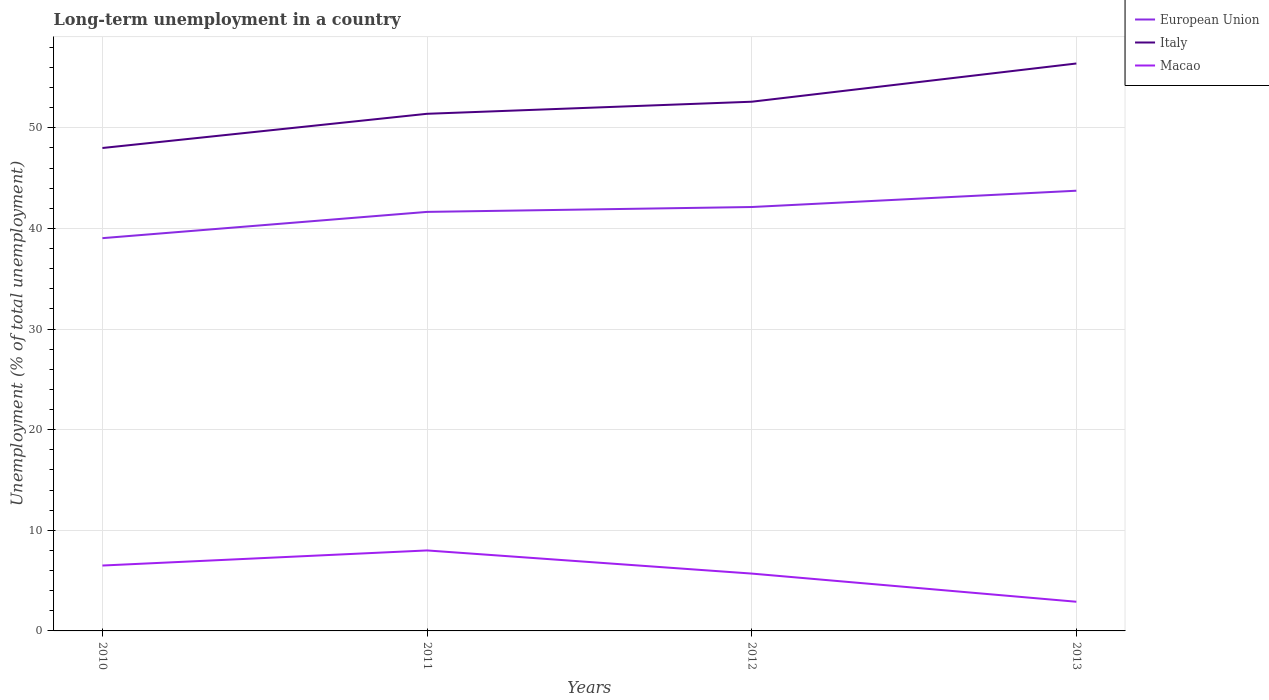Does the line corresponding to Italy intersect with the line corresponding to Macao?
Give a very brief answer. No. In which year was the percentage of long-term unemployed population in Italy maximum?
Make the answer very short. 2010. What is the total percentage of long-term unemployed population in Macao in the graph?
Your response must be concise. 5.1. What is the difference between the highest and the second highest percentage of long-term unemployed population in Italy?
Your answer should be compact. 8.4. What is the difference between the highest and the lowest percentage of long-term unemployed population in Macao?
Keep it short and to the point. 2. How many lines are there?
Ensure brevity in your answer.  3. How many years are there in the graph?
Offer a very short reply. 4. What is the difference between two consecutive major ticks on the Y-axis?
Provide a succinct answer. 10. Are the values on the major ticks of Y-axis written in scientific E-notation?
Keep it short and to the point. No. Does the graph contain any zero values?
Offer a very short reply. No. Does the graph contain grids?
Your response must be concise. Yes. How are the legend labels stacked?
Ensure brevity in your answer.  Vertical. What is the title of the graph?
Provide a short and direct response. Long-term unemployment in a country. What is the label or title of the Y-axis?
Your answer should be compact. Unemployment (% of total unemployment). What is the Unemployment (% of total unemployment) in European Union in 2010?
Your response must be concise. 39.04. What is the Unemployment (% of total unemployment) in Italy in 2010?
Offer a very short reply. 48. What is the Unemployment (% of total unemployment) in Macao in 2010?
Your answer should be very brief. 6.5. What is the Unemployment (% of total unemployment) in European Union in 2011?
Provide a short and direct response. 41.65. What is the Unemployment (% of total unemployment) of Italy in 2011?
Provide a succinct answer. 51.4. What is the Unemployment (% of total unemployment) in Macao in 2011?
Ensure brevity in your answer.  8. What is the Unemployment (% of total unemployment) of European Union in 2012?
Offer a very short reply. 42.13. What is the Unemployment (% of total unemployment) in Italy in 2012?
Your answer should be compact. 52.6. What is the Unemployment (% of total unemployment) in Macao in 2012?
Offer a terse response. 5.7. What is the Unemployment (% of total unemployment) of European Union in 2013?
Your answer should be compact. 43.75. What is the Unemployment (% of total unemployment) of Italy in 2013?
Offer a terse response. 56.4. What is the Unemployment (% of total unemployment) of Macao in 2013?
Ensure brevity in your answer.  2.9. Across all years, what is the maximum Unemployment (% of total unemployment) in European Union?
Offer a very short reply. 43.75. Across all years, what is the maximum Unemployment (% of total unemployment) of Italy?
Provide a succinct answer. 56.4. Across all years, what is the maximum Unemployment (% of total unemployment) of Macao?
Offer a terse response. 8. Across all years, what is the minimum Unemployment (% of total unemployment) of European Union?
Your response must be concise. 39.04. Across all years, what is the minimum Unemployment (% of total unemployment) of Italy?
Make the answer very short. 48. Across all years, what is the minimum Unemployment (% of total unemployment) in Macao?
Make the answer very short. 2.9. What is the total Unemployment (% of total unemployment) in European Union in the graph?
Offer a very short reply. 166.58. What is the total Unemployment (% of total unemployment) of Italy in the graph?
Make the answer very short. 208.4. What is the total Unemployment (% of total unemployment) in Macao in the graph?
Offer a terse response. 23.1. What is the difference between the Unemployment (% of total unemployment) in European Union in 2010 and that in 2011?
Your answer should be very brief. -2.61. What is the difference between the Unemployment (% of total unemployment) of Italy in 2010 and that in 2011?
Offer a terse response. -3.4. What is the difference between the Unemployment (% of total unemployment) in European Union in 2010 and that in 2012?
Keep it short and to the point. -3.09. What is the difference between the Unemployment (% of total unemployment) of Macao in 2010 and that in 2012?
Offer a terse response. 0.8. What is the difference between the Unemployment (% of total unemployment) in European Union in 2010 and that in 2013?
Offer a very short reply. -4.71. What is the difference between the Unemployment (% of total unemployment) in Macao in 2010 and that in 2013?
Offer a very short reply. 3.6. What is the difference between the Unemployment (% of total unemployment) in European Union in 2011 and that in 2012?
Offer a terse response. -0.48. What is the difference between the Unemployment (% of total unemployment) in Macao in 2011 and that in 2012?
Ensure brevity in your answer.  2.3. What is the difference between the Unemployment (% of total unemployment) of European Union in 2011 and that in 2013?
Give a very brief answer. -2.1. What is the difference between the Unemployment (% of total unemployment) in Italy in 2011 and that in 2013?
Your answer should be very brief. -5. What is the difference between the Unemployment (% of total unemployment) of Macao in 2011 and that in 2013?
Provide a succinct answer. 5.1. What is the difference between the Unemployment (% of total unemployment) of European Union in 2012 and that in 2013?
Your response must be concise. -1.62. What is the difference between the Unemployment (% of total unemployment) in Italy in 2012 and that in 2013?
Provide a short and direct response. -3.8. What is the difference between the Unemployment (% of total unemployment) in Macao in 2012 and that in 2013?
Ensure brevity in your answer.  2.8. What is the difference between the Unemployment (% of total unemployment) of European Union in 2010 and the Unemployment (% of total unemployment) of Italy in 2011?
Provide a short and direct response. -12.36. What is the difference between the Unemployment (% of total unemployment) in European Union in 2010 and the Unemployment (% of total unemployment) in Macao in 2011?
Offer a terse response. 31.04. What is the difference between the Unemployment (% of total unemployment) of European Union in 2010 and the Unemployment (% of total unemployment) of Italy in 2012?
Offer a very short reply. -13.56. What is the difference between the Unemployment (% of total unemployment) in European Union in 2010 and the Unemployment (% of total unemployment) in Macao in 2012?
Your response must be concise. 33.34. What is the difference between the Unemployment (% of total unemployment) of Italy in 2010 and the Unemployment (% of total unemployment) of Macao in 2012?
Your answer should be compact. 42.3. What is the difference between the Unemployment (% of total unemployment) in European Union in 2010 and the Unemployment (% of total unemployment) in Italy in 2013?
Your answer should be very brief. -17.36. What is the difference between the Unemployment (% of total unemployment) in European Union in 2010 and the Unemployment (% of total unemployment) in Macao in 2013?
Keep it short and to the point. 36.14. What is the difference between the Unemployment (% of total unemployment) of Italy in 2010 and the Unemployment (% of total unemployment) of Macao in 2013?
Your answer should be very brief. 45.1. What is the difference between the Unemployment (% of total unemployment) in European Union in 2011 and the Unemployment (% of total unemployment) in Italy in 2012?
Keep it short and to the point. -10.95. What is the difference between the Unemployment (% of total unemployment) in European Union in 2011 and the Unemployment (% of total unemployment) in Macao in 2012?
Ensure brevity in your answer.  35.95. What is the difference between the Unemployment (% of total unemployment) of Italy in 2011 and the Unemployment (% of total unemployment) of Macao in 2012?
Provide a short and direct response. 45.7. What is the difference between the Unemployment (% of total unemployment) of European Union in 2011 and the Unemployment (% of total unemployment) of Italy in 2013?
Your response must be concise. -14.75. What is the difference between the Unemployment (% of total unemployment) of European Union in 2011 and the Unemployment (% of total unemployment) of Macao in 2013?
Your answer should be very brief. 38.75. What is the difference between the Unemployment (% of total unemployment) of Italy in 2011 and the Unemployment (% of total unemployment) of Macao in 2013?
Your answer should be very brief. 48.5. What is the difference between the Unemployment (% of total unemployment) in European Union in 2012 and the Unemployment (% of total unemployment) in Italy in 2013?
Your response must be concise. -14.27. What is the difference between the Unemployment (% of total unemployment) of European Union in 2012 and the Unemployment (% of total unemployment) of Macao in 2013?
Make the answer very short. 39.23. What is the difference between the Unemployment (% of total unemployment) of Italy in 2012 and the Unemployment (% of total unemployment) of Macao in 2013?
Provide a short and direct response. 49.7. What is the average Unemployment (% of total unemployment) in European Union per year?
Provide a short and direct response. 41.64. What is the average Unemployment (% of total unemployment) of Italy per year?
Offer a terse response. 52.1. What is the average Unemployment (% of total unemployment) of Macao per year?
Give a very brief answer. 5.78. In the year 2010, what is the difference between the Unemployment (% of total unemployment) of European Union and Unemployment (% of total unemployment) of Italy?
Your answer should be compact. -8.96. In the year 2010, what is the difference between the Unemployment (% of total unemployment) of European Union and Unemployment (% of total unemployment) of Macao?
Your answer should be very brief. 32.54. In the year 2010, what is the difference between the Unemployment (% of total unemployment) in Italy and Unemployment (% of total unemployment) in Macao?
Your response must be concise. 41.5. In the year 2011, what is the difference between the Unemployment (% of total unemployment) in European Union and Unemployment (% of total unemployment) in Italy?
Offer a terse response. -9.75. In the year 2011, what is the difference between the Unemployment (% of total unemployment) of European Union and Unemployment (% of total unemployment) of Macao?
Offer a very short reply. 33.65. In the year 2011, what is the difference between the Unemployment (% of total unemployment) of Italy and Unemployment (% of total unemployment) of Macao?
Your response must be concise. 43.4. In the year 2012, what is the difference between the Unemployment (% of total unemployment) of European Union and Unemployment (% of total unemployment) of Italy?
Your answer should be compact. -10.47. In the year 2012, what is the difference between the Unemployment (% of total unemployment) of European Union and Unemployment (% of total unemployment) of Macao?
Offer a very short reply. 36.43. In the year 2012, what is the difference between the Unemployment (% of total unemployment) of Italy and Unemployment (% of total unemployment) of Macao?
Make the answer very short. 46.9. In the year 2013, what is the difference between the Unemployment (% of total unemployment) of European Union and Unemployment (% of total unemployment) of Italy?
Provide a short and direct response. -12.65. In the year 2013, what is the difference between the Unemployment (% of total unemployment) in European Union and Unemployment (% of total unemployment) in Macao?
Provide a succinct answer. 40.85. In the year 2013, what is the difference between the Unemployment (% of total unemployment) in Italy and Unemployment (% of total unemployment) in Macao?
Offer a very short reply. 53.5. What is the ratio of the Unemployment (% of total unemployment) in European Union in 2010 to that in 2011?
Provide a short and direct response. 0.94. What is the ratio of the Unemployment (% of total unemployment) of Italy in 2010 to that in 2011?
Make the answer very short. 0.93. What is the ratio of the Unemployment (% of total unemployment) in Macao in 2010 to that in 2011?
Your response must be concise. 0.81. What is the ratio of the Unemployment (% of total unemployment) of European Union in 2010 to that in 2012?
Your answer should be very brief. 0.93. What is the ratio of the Unemployment (% of total unemployment) in Italy in 2010 to that in 2012?
Make the answer very short. 0.91. What is the ratio of the Unemployment (% of total unemployment) of Macao in 2010 to that in 2012?
Provide a succinct answer. 1.14. What is the ratio of the Unemployment (% of total unemployment) in European Union in 2010 to that in 2013?
Provide a succinct answer. 0.89. What is the ratio of the Unemployment (% of total unemployment) of Italy in 2010 to that in 2013?
Offer a terse response. 0.85. What is the ratio of the Unemployment (% of total unemployment) in Macao in 2010 to that in 2013?
Your answer should be compact. 2.24. What is the ratio of the Unemployment (% of total unemployment) of Italy in 2011 to that in 2012?
Ensure brevity in your answer.  0.98. What is the ratio of the Unemployment (% of total unemployment) of Macao in 2011 to that in 2012?
Your response must be concise. 1.4. What is the ratio of the Unemployment (% of total unemployment) in European Union in 2011 to that in 2013?
Ensure brevity in your answer.  0.95. What is the ratio of the Unemployment (% of total unemployment) of Italy in 2011 to that in 2013?
Your answer should be compact. 0.91. What is the ratio of the Unemployment (% of total unemployment) of Macao in 2011 to that in 2013?
Offer a terse response. 2.76. What is the ratio of the Unemployment (% of total unemployment) in Italy in 2012 to that in 2013?
Ensure brevity in your answer.  0.93. What is the ratio of the Unemployment (% of total unemployment) in Macao in 2012 to that in 2013?
Keep it short and to the point. 1.97. What is the difference between the highest and the second highest Unemployment (% of total unemployment) of European Union?
Your answer should be compact. 1.62. What is the difference between the highest and the second highest Unemployment (% of total unemployment) of Italy?
Your answer should be compact. 3.8. What is the difference between the highest and the second highest Unemployment (% of total unemployment) in Macao?
Give a very brief answer. 1.5. What is the difference between the highest and the lowest Unemployment (% of total unemployment) of European Union?
Offer a very short reply. 4.71. 